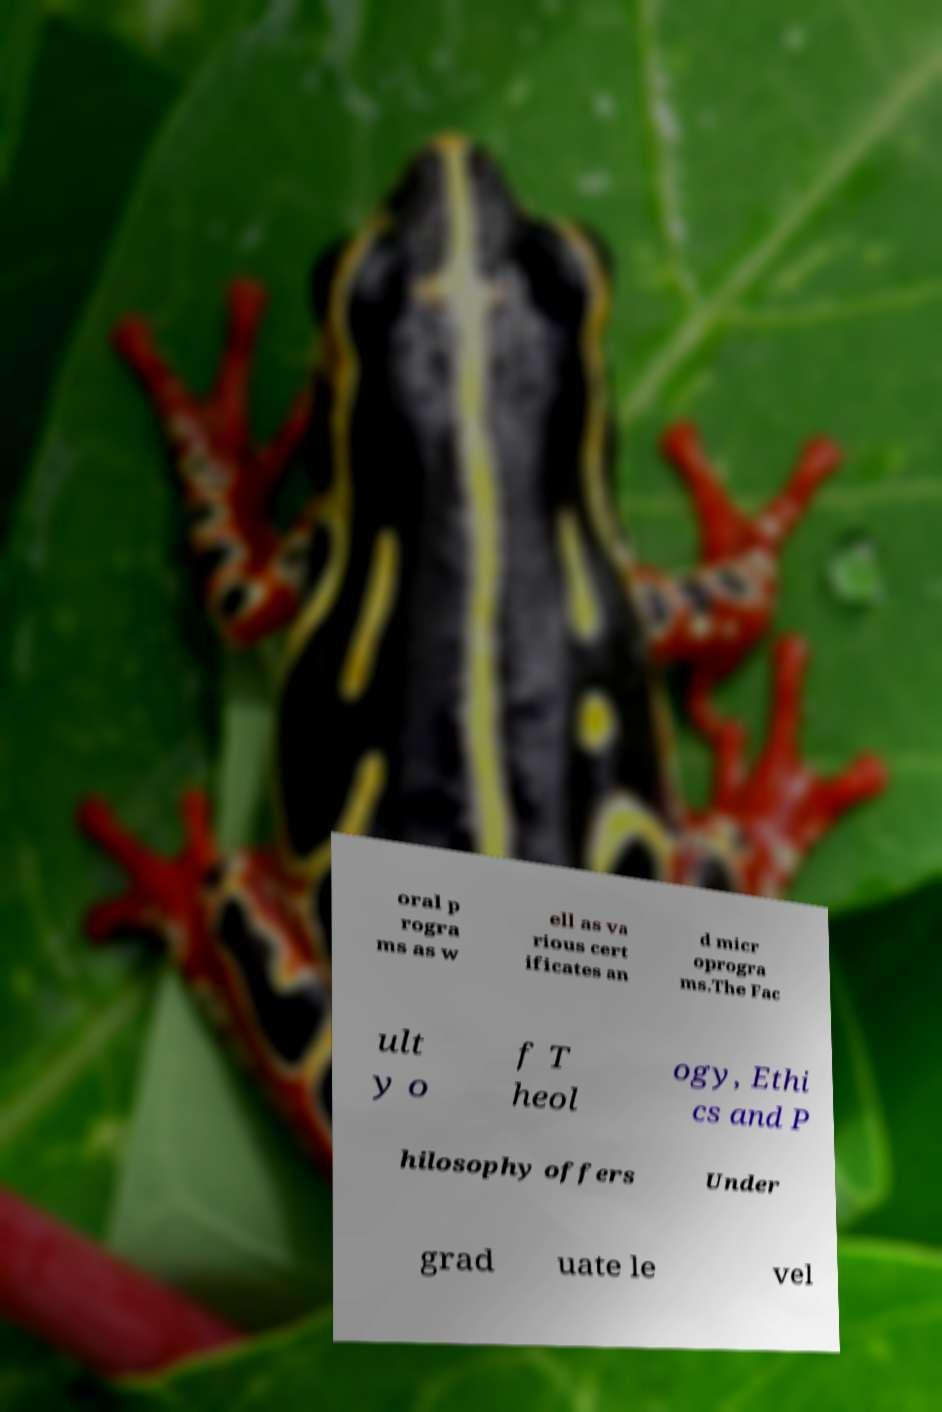There's text embedded in this image that I need extracted. Can you transcribe it verbatim? oral p rogra ms as w ell as va rious cert ificates an d micr oprogra ms.The Fac ult y o f T heol ogy, Ethi cs and P hilosophy offers Under grad uate le vel 